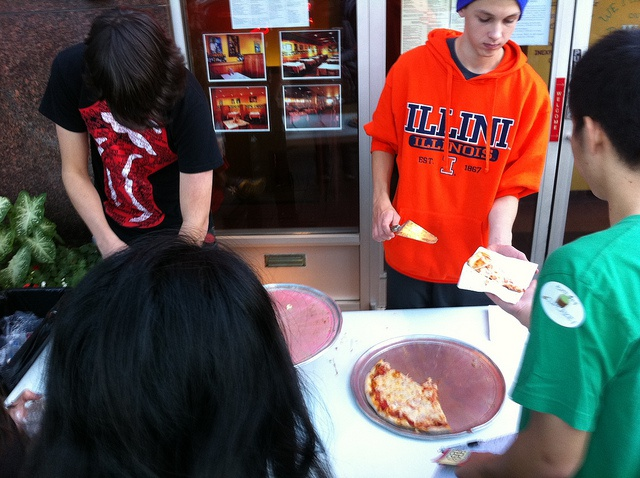Describe the objects in this image and their specific colors. I can see people in black, gray, and darkblue tones, people in black, teal, and turquoise tones, people in black, red, and brown tones, people in black, maroon, lightpink, and darkgray tones, and potted plant in black, darkgreen, and gray tones in this image. 